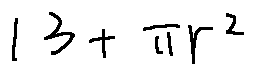<formula> <loc_0><loc_0><loc_500><loc_500>1 3 + \pi r ^ { 2 }</formula> 